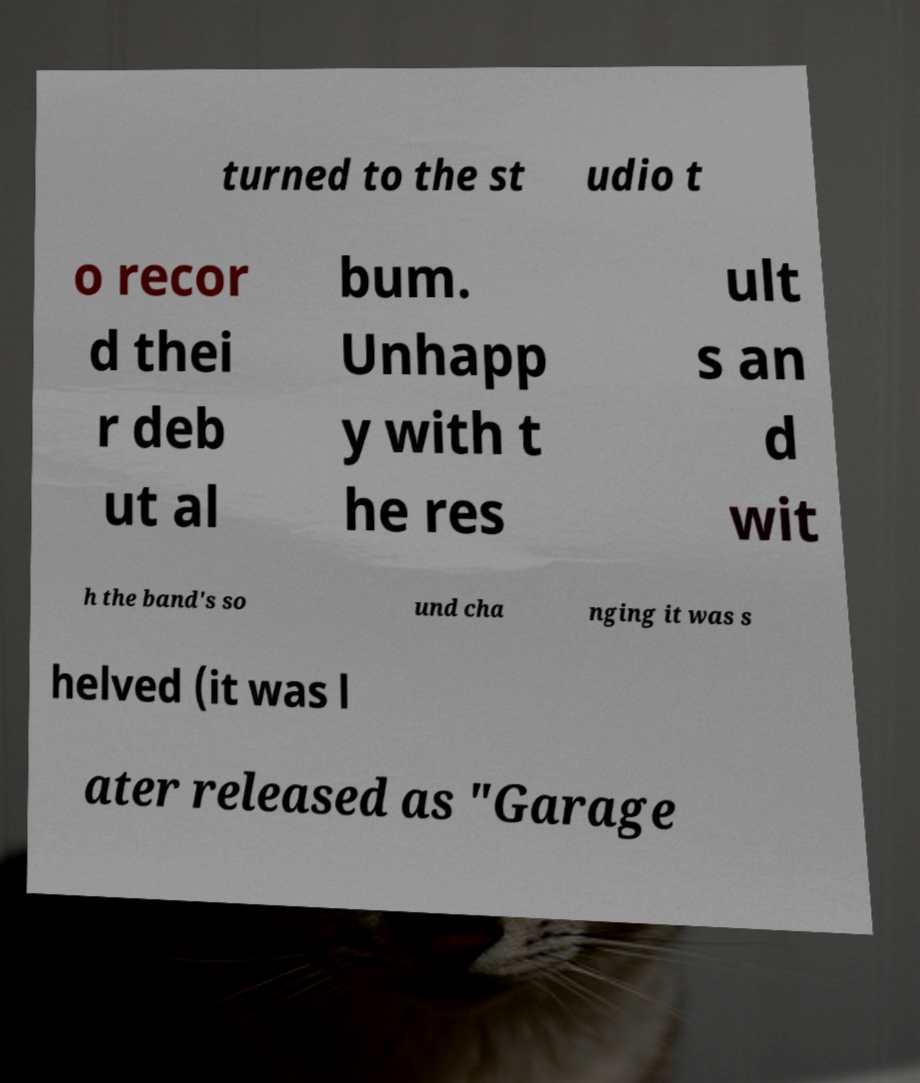Please read and relay the text visible in this image. What does it say? turned to the st udio t o recor d thei r deb ut al bum. Unhapp y with t he res ult s an d wit h the band's so und cha nging it was s helved (it was l ater released as "Garage 